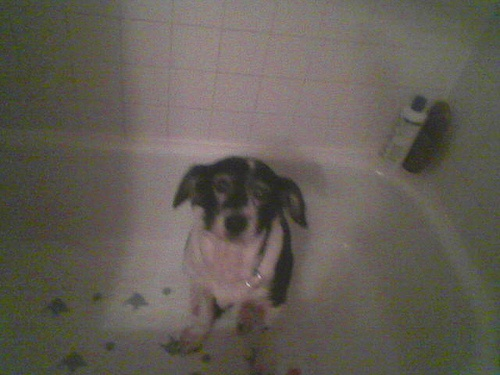Describe the objects in this image and their specific colors. I can see dog in darkgreen, black, and gray tones and bottle in darkgreen, gray, and black tones in this image. 